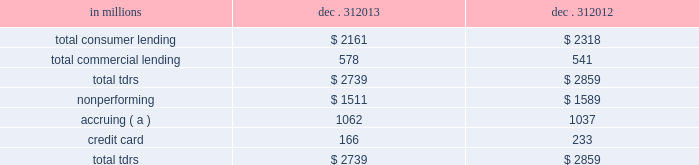Troubled debt restructurings ( tdrs ) a tdr is a loan whose terms have been restructured in a manner that grants a concession to a borrower experiencing financial difficulties .
Tdrs result from our loss mitigation activities , and include rate reductions , principal forgiveness , postponement/reduction of scheduled amortization , and extensions , which are intended to minimize economic loss and to avoid foreclosure or repossession of collateral .
Additionally , tdrs also result from borrowers that have been discharged from personal liability through chapter 7 bankruptcy and have not formally reaffirmed their loan obligations to pnc .
In those situations where principal is forgiven , the amount of such principal forgiveness is immediately charged off .
Some tdrs may not ultimately result in the full collection of principal and interest , as restructured , and result in potential incremental losses .
These potential incremental losses have been factored into our overall alll estimate .
The level of any subsequent defaults will likely be affected by future economic conditions .
Once a loan becomes a tdr , it will continue to be reported as a tdr until it is ultimately repaid in full , the collateral is foreclosed upon , or it is fully charged off .
We held specific reserves in the alll of $ .5 billion and $ .6 billion at december 31 , 2013 and december 31 , 2012 , respectively , for the total tdr portfolio .
Table 70 : summary of troubled debt restructurings in millions dec .
31 dec .
31 .
( a ) accruing loans have demonstrated a period of at least six months of performance under the restructured terms and are excluded from nonperforming loans .
Loans where borrowers have been discharged from personal liability through chapter 7 bankruptcy and have not formally reaffirmed their loan obligations to pnc are not returned to accrual status .
Table 71 quantifies the number of loans that were classified as tdrs as well as the change in the recorded investments as a result of the tdr classification during 2013 , 2012 and 2011 .
Additionally , the table provides information about the types of tdr concessions .
The principal forgiveness tdr category includes principal forgiveness and accrued interest forgiveness .
These types of tdrs result in a write down of the recorded investment and a charge-off if such action has not already taken place .
The rate reduction tdr category includes reduced interest rate and interest deferral .
The tdrs within this category would result in reductions to future interest income .
The other tdr category primarily includes consumer borrowers that have been discharged from personal liability through chapter 7 bankruptcy and have not formally reaffirmed their loan obligations to pnc , as well as postponement/reduction of scheduled amortization and contractual extensions for both consumer and commercial borrowers .
In some cases , there have been multiple concessions granted on one loan .
This is most common within the commercial loan portfolio .
When there have been multiple concessions granted in the commercial loan portfolio , the principal forgiveness tdr was prioritized for purposes of determining the inclusion in the table below .
For example , if there is principal forgiveness in conjunction with lower interest rate and postponement of amortization , the type of concession will be reported as principal forgiveness .
Second in priority would be rate reduction .
For example , if there is an interest rate reduction in conjunction with postponement of amortization , the type of concession will be reported as a rate reduction .
In the event that multiple concessions are granted on a consumer loan , concessions resulting from discharge from personal liability through chapter 7 bankruptcy without formal affirmation of the loan obligations to pnc would be prioritized and included in the other type of concession in the table below .
After that , consumer loan concessions would follow the previously discussed priority of concessions for the commercial loan portfolio .
140 the pnc financial services group , inc .
2013 form 10-k .
In millions for the two years ended dec . 312013 and dec . 312012 , \\nwhat was the average balance of total tdrs? 
Computations: table_average(total tdrs, none)
Answer: 2799.0. 